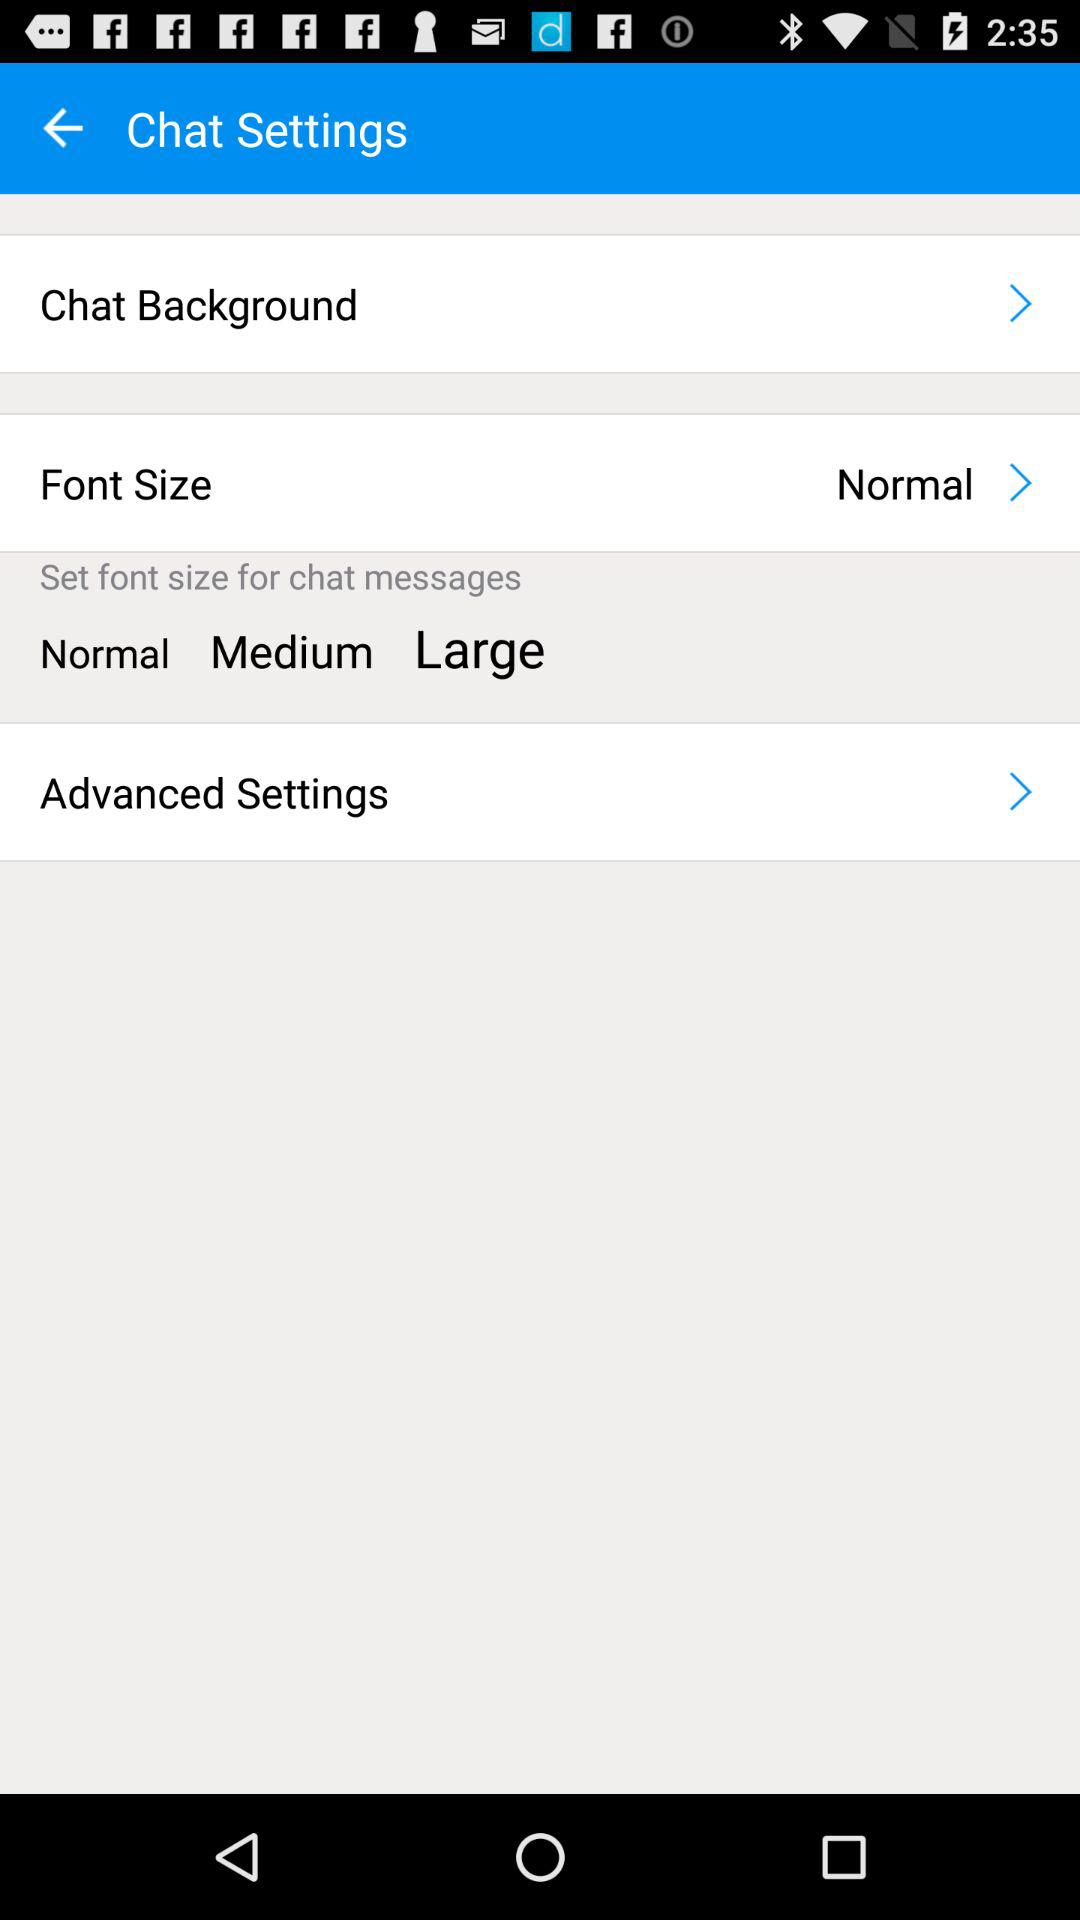How many font sizes are available for chat messages?
Answer the question using a single word or phrase. 3 